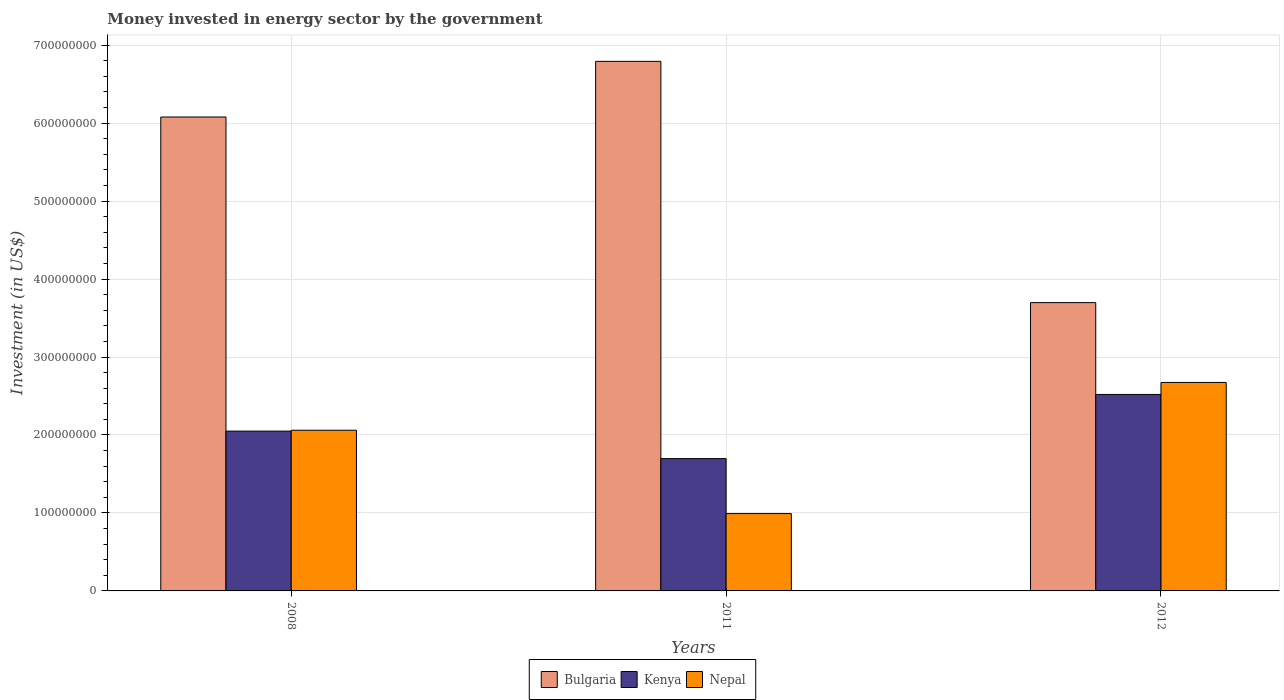How many groups of bars are there?
Provide a short and direct response. 3. Are the number of bars per tick equal to the number of legend labels?
Provide a short and direct response. Yes. Are the number of bars on each tick of the X-axis equal?
Give a very brief answer. Yes. How many bars are there on the 2nd tick from the right?
Your answer should be compact. 3. In how many cases, is the number of bars for a given year not equal to the number of legend labels?
Keep it short and to the point. 0. What is the money spent in energy sector in Bulgaria in 2008?
Your answer should be very brief. 6.08e+08. Across all years, what is the maximum money spent in energy sector in Nepal?
Keep it short and to the point. 2.67e+08. Across all years, what is the minimum money spent in energy sector in Bulgaria?
Ensure brevity in your answer.  3.70e+08. In which year was the money spent in energy sector in Nepal maximum?
Offer a very short reply. 2012. In which year was the money spent in energy sector in Nepal minimum?
Offer a very short reply. 2011. What is the total money spent in energy sector in Kenya in the graph?
Provide a short and direct response. 6.27e+08. What is the difference between the money spent in energy sector in Kenya in 2008 and that in 2011?
Your answer should be compact. 3.53e+07. What is the difference between the money spent in energy sector in Nepal in 2008 and the money spent in energy sector in Kenya in 2012?
Your response must be concise. -4.59e+07. What is the average money spent in energy sector in Bulgaria per year?
Offer a very short reply. 5.52e+08. In the year 2012, what is the difference between the money spent in energy sector in Nepal and money spent in energy sector in Bulgaria?
Make the answer very short. -1.02e+08. What is the ratio of the money spent in energy sector in Nepal in 2008 to that in 2011?
Your answer should be compact. 2.08. What is the difference between the highest and the second highest money spent in energy sector in Nepal?
Provide a short and direct response. 6.13e+07. What is the difference between the highest and the lowest money spent in energy sector in Nepal?
Your response must be concise. 1.68e+08. In how many years, is the money spent in energy sector in Bulgaria greater than the average money spent in energy sector in Bulgaria taken over all years?
Your answer should be very brief. 2. Is the sum of the money spent in energy sector in Nepal in 2011 and 2012 greater than the maximum money spent in energy sector in Bulgaria across all years?
Keep it short and to the point. No. What does the 2nd bar from the left in 2012 represents?
Provide a short and direct response. Kenya. What does the 2nd bar from the right in 2008 represents?
Keep it short and to the point. Kenya. Is it the case that in every year, the sum of the money spent in energy sector in Bulgaria and money spent in energy sector in Nepal is greater than the money spent in energy sector in Kenya?
Your response must be concise. Yes. Are all the bars in the graph horizontal?
Your answer should be very brief. No. What is the difference between two consecutive major ticks on the Y-axis?
Give a very brief answer. 1.00e+08. Are the values on the major ticks of Y-axis written in scientific E-notation?
Your answer should be compact. No. How are the legend labels stacked?
Provide a succinct answer. Horizontal. What is the title of the graph?
Your answer should be compact. Money invested in energy sector by the government. Does "Dominica" appear as one of the legend labels in the graph?
Your answer should be compact. No. What is the label or title of the X-axis?
Give a very brief answer. Years. What is the label or title of the Y-axis?
Provide a succinct answer. Investment (in US$). What is the Investment (in US$) of Bulgaria in 2008?
Ensure brevity in your answer.  6.08e+08. What is the Investment (in US$) of Kenya in 2008?
Make the answer very short. 2.05e+08. What is the Investment (in US$) in Nepal in 2008?
Give a very brief answer. 2.06e+08. What is the Investment (in US$) in Bulgaria in 2011?
Give a very brief answer. 6.79e+08. What is the Investment (in US$) of Kenya in 2011?
Give a very brief answer. 1.70e+08. What is the Investment (in US$) of Nepal in 2011?
Give a very brief answer. 9.92e+07. What is the Investment (in US$) of Bulgaria in 2012?
Offer a very short reply. 3.70e+08. What is the Investment (in US$) of Kenya in 2012?
Provide a succinct answer. 2.52e+08. What is the Investment (in US$) of Nepal in 2012?
Offer a terse response. 2.67e+08. Across all years, what is the maximum Investment (in US$) in Bulgaria?
Your answer should be compact. 6.79e+08. Across all years, what is the maximum Investment (in US$) of Kenya?
Ensure brevity in your answer.  2.52e+08. Across all years, what is the maximum Investment (in US$) in Nepal?
Provide a short and direct response. 2.67e+08. Across all years, what is the minimum Investment (in US$) in Bulgaria?
Offer a very short reply. 3.70e+08. Across all years, what is the minimum Investment (in US$) in Kenya?
Give a very brief answer. 1.70e+08. Across all years, what is the minimum Investment (in US$) in Nepal?
Offer a very short reply. 9.92e+07. What is the total Investment (in US$) of Bulgaria in the graph?
Give a very brief answer. 1.66e+09. What is the total Investment (in US$) in Kenya in the graph?
Ensure brevity in your answer.  6.27e+08. What is the total Investment (in US$) of Nepal in the graph?
Provide a succinct answer. 5.73e+08. What is the difference between the Investment (in US$) in Bulgaria in 2008 and that in 2011?
Ensure brevity in your answer.  -7.14e+07. What is the difference between the Investment (in US$) in Kenya in 2008 and that in 2011?
Provide a succinct answer. 3.53e+07. What is the difference between the Investment (in US$) of Nepal in 2008 and that in 2011?
Offer a terse response. 1.07e+08. What is the difference between the Investment (in US$) of Bulgaria in 2008 and that in 2012?
Provide a short and direct response. 2.38e+08. What is the difference between the Investment (in US$) of Kenya in 2008 and that in 2012?
Your answer should be compact. -4.70e+07. What is the difference between the Investment (in US$) of Nepal in 2008 and that in 2012?
Make the answer very short. -6.13e+07. What is the difference between the Investment (in US$) in Bulgaria in 2011 and that in 2012?
Keep it short and to the point. 3.09e+08. What is the difference between the Investment (in US$) of Kenya in 2011 and that in 2012?
Ensure brevity in your answer.  -8.23e+07. What is the difference between the Investment (in US$) of Nepal in 2011 and that in 2012?
Make the answer very short. -1.68e+08. What is the difference between the Investment (in US$) of Bulgaria in 2008 and the Investment (in US$) of Kenya in 2011?
Keep it short and to the point. 4.38e+08. What is the difference between the Investment (in US$) in Bulgaria in 2008 and the Investment (in US$) in Nepal in 2011?
Your response must be concise. 5.09e+08. What is the difference between the Investment (in US$) of Kenya in 2008 and the Investment (in US$) of Nepal in 2011?
Give a very brief answer. 1.06e+08. What is the difference between the Investment (in US$) of Bulgaria in 2008 and the Investment (in US$) of Kenya in 2012?
Provide a succinct answer. 3.56e+08. What is the difference between the Investment (in US$) of Bulgaria in 2008 and the Investment (in US$) of Nepal in 2012?
Your response must be concise. 3.40e+08. What is the difference between the Investment (in US$) of Kenya in 2008 and the Investment (in US$) of Nepal in 2012?
Ensure brevity in your answer.  -6.24e+07. What is the difference between the Investment (in US$) in Bulgaria in 2011 and the Investment (in US$) in Kenya in 2012?
Provide a succinct answer. 4.27e+08. What is the difference between the Investment (in US$) in Bulgaria in 2011 and the Investment (in US$) in Nepal in 2012?
Your response must be concise. 4.12e+08. What is the difference between the Investment (in US$) of Kenya in 2011 and the Investment (in US$) of Nepal in 2012?
Your answer should be very brief. -9.77e+07. What is the average Investment (in US$) of Bulgaria per year?
Offer a very short reply. 5.52e+08. What is the average Investment (in US$) in Kenya per year?
Ensure brevity in your answer.  2.09e+08. What is the average Investment (in US$) in Nepal per year?
Provide a succinct answer. 1.91e+08. In the year 2008, what is the difference between the Investment (in US$) of Bulgaria and Investment (in US$) of Kenya?
Offer a very short reply. 4.03e+08. In the year 2008, what is the difference between the Investment (in US$) of Bulgaria and Investment (in US$) of Nepal?
Your answer should be very brief. 4.02e+08. In the year 2008, what is the difference between the Investment (in US$) of Kenya and Investment (in US$) of Nepal?
Keep it short and to the point. -1.10e+06. In the year 2011, what is the difference between the Investment (in US$) in Bulgaria and Investment (in US$) in Kenya?
Offer a very short reply. 5.10e+08. In the year 2011, what is the difference between the Investment (in US$) in Bulgaria and Investment (in US$) in Nepal?
Your answer should be compact. 5.80e+08. In the year 2011, what is the difference between the Investment (in US$) of Kenya and Investment (in US$) of Nepal?
Provide a short and direct response. 7.05e+07. In the year 2012, what is the difference between the Investment (in US$) in Bulgaria and Investment (in US$) in Kenya?
Provide a succinct answer. 1.18e+08. In the year 2012, what is the difference between the Investment (in US$) in Bulgaria and Investment (in US$) in Nepal?
Make the answer very short. 1.02e+08. In the year 2012, what is the difference between the Investment (in US$) of Kenya and Investment (in US$) of Nepal?
Give a very brief answer. -1.54e+07. What is the ratio of the Investment (in US$) of Bulgaria in 2008 to that in 2011?
Make the answer very short. 0.89. What is the ratio of the Investment (in US$) in Kenya in 2008 to that in 2011?
Keep it short and to the point. 1.21. What is the ratio of the Investment (in US$) of Nepal in 2008 to that in 2011?
Ensure brevity in your answer.  2.08. What is the ratio of the Investment (in US$) of Bulgaria in 2008 to that in 2012?
Offer a terse response. 1.64. What is the ratio of the Investment (in US$) of Kenya in 2008 to that in 2012?
Provide a short and direct response. 0.81. What is the ratio of the Investment (in US$) of Nepal in 2008 to that in 2012?
Provide a succinct answer. 0.77. What is the ratio of the Investment (in US$) in Bulgaria in 2011 to that in 2012?
Your answer should be very brief. 1.84. What is the ratio of the Investment (in US$) in Kenya in 2011 to that in 2012?
Your answer should be compact. 0.67. What is the ratio of the Investment (in US$) of Nepal in 2011 to that in 2012?
Your answer should be very brief. 0.37. What is the difference between the highest and the second highest Investment (in US$) in Bulgaria?
Ensure brevity in your answer.  7.14e+07. What is the difference between the highest and the second highest Investment (in US$) in Kenya?
Make the answer very short. 4.70e+07. What is the difference between the highest and the second highest Investment (in US$) in Nepal?
Give a very brief answer. 6.13e+07. What is the difference between the highest and the lowest Investment (in US$) in Bulgaria?
Provide a succinct answer. 3.09e+08. What is the difference between the highest and the lowest Investment (in US$) of Kenya?
Give a very brief answer. 8.23e+07. What is the difference between the highest and the lowest Investment (in US$) of Nepal?
Your response must be concise. 1.68e+08. 